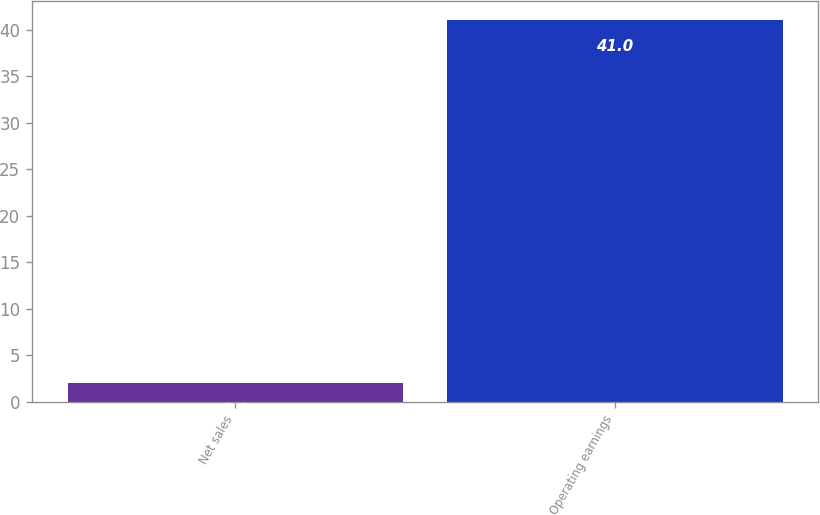Convert chart. <chart><loc_0><loc_0><loc_500><loc_500><bar_chart><fcel>Net sales<fcel>Operating earnings<nl><fcel>2<fcel>41<nl></chart> 